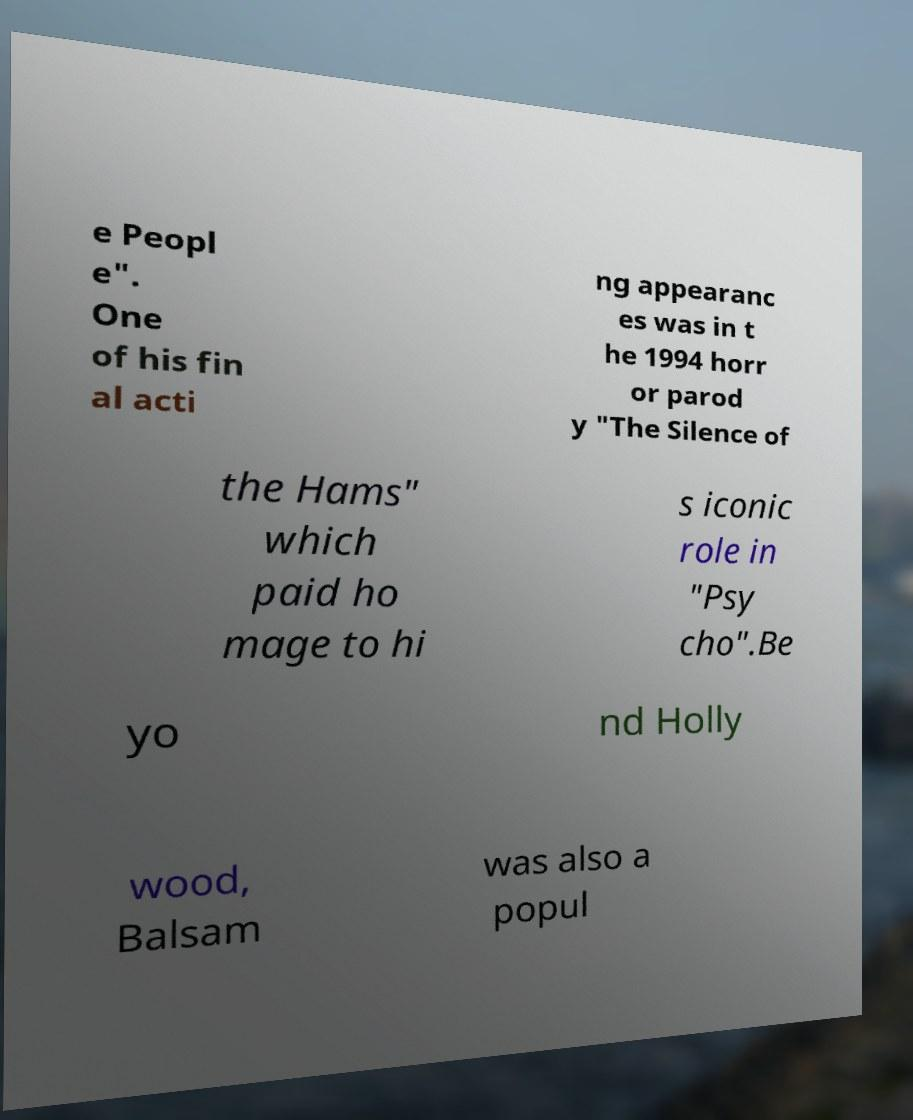Could you assist in decoding the text presented in this image and type it out clearly? e Peopl e". One of his fin al acti ng appearanc es was in t he 1994 horr or parod y "The Silence of the Hams" which paid ho mage to hi s iconic role in "Psy cho".Be yo nd Holly wood, Balsam was also a popul 